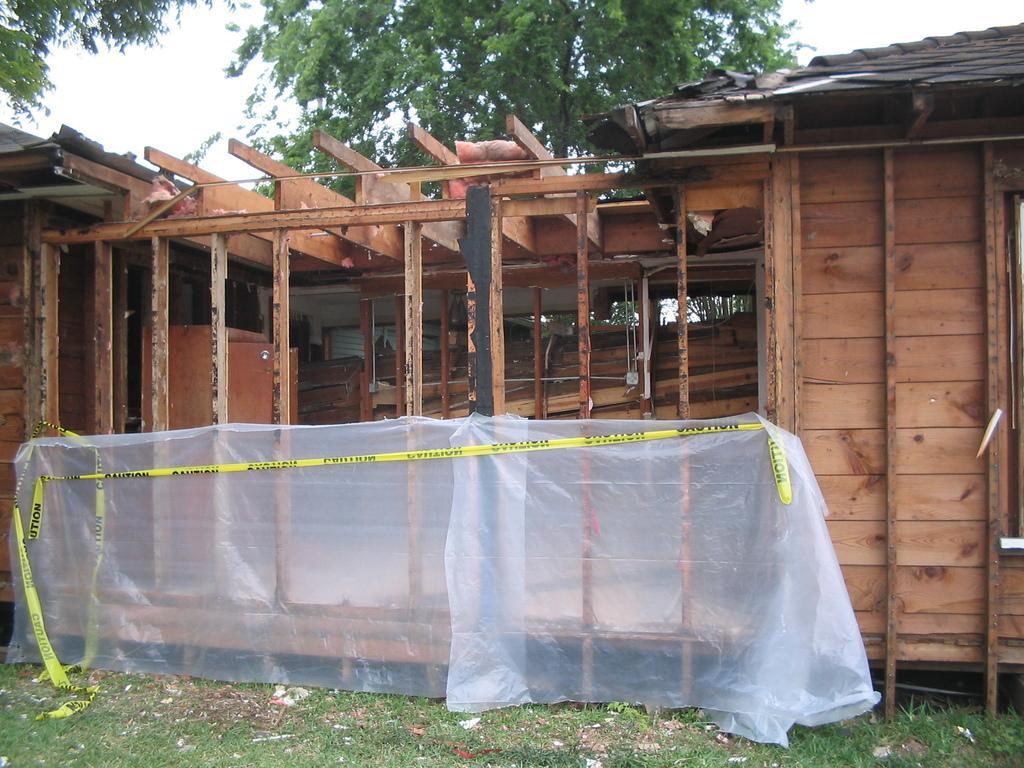How would you summarize this image in a sentence or two? In this image, we can see a wooden house. We can see the wall and some wooden objects. We can also see some cover and the banner. We can see the ground covered with grass and some objects. There are a few trees. We can also see the sky. 